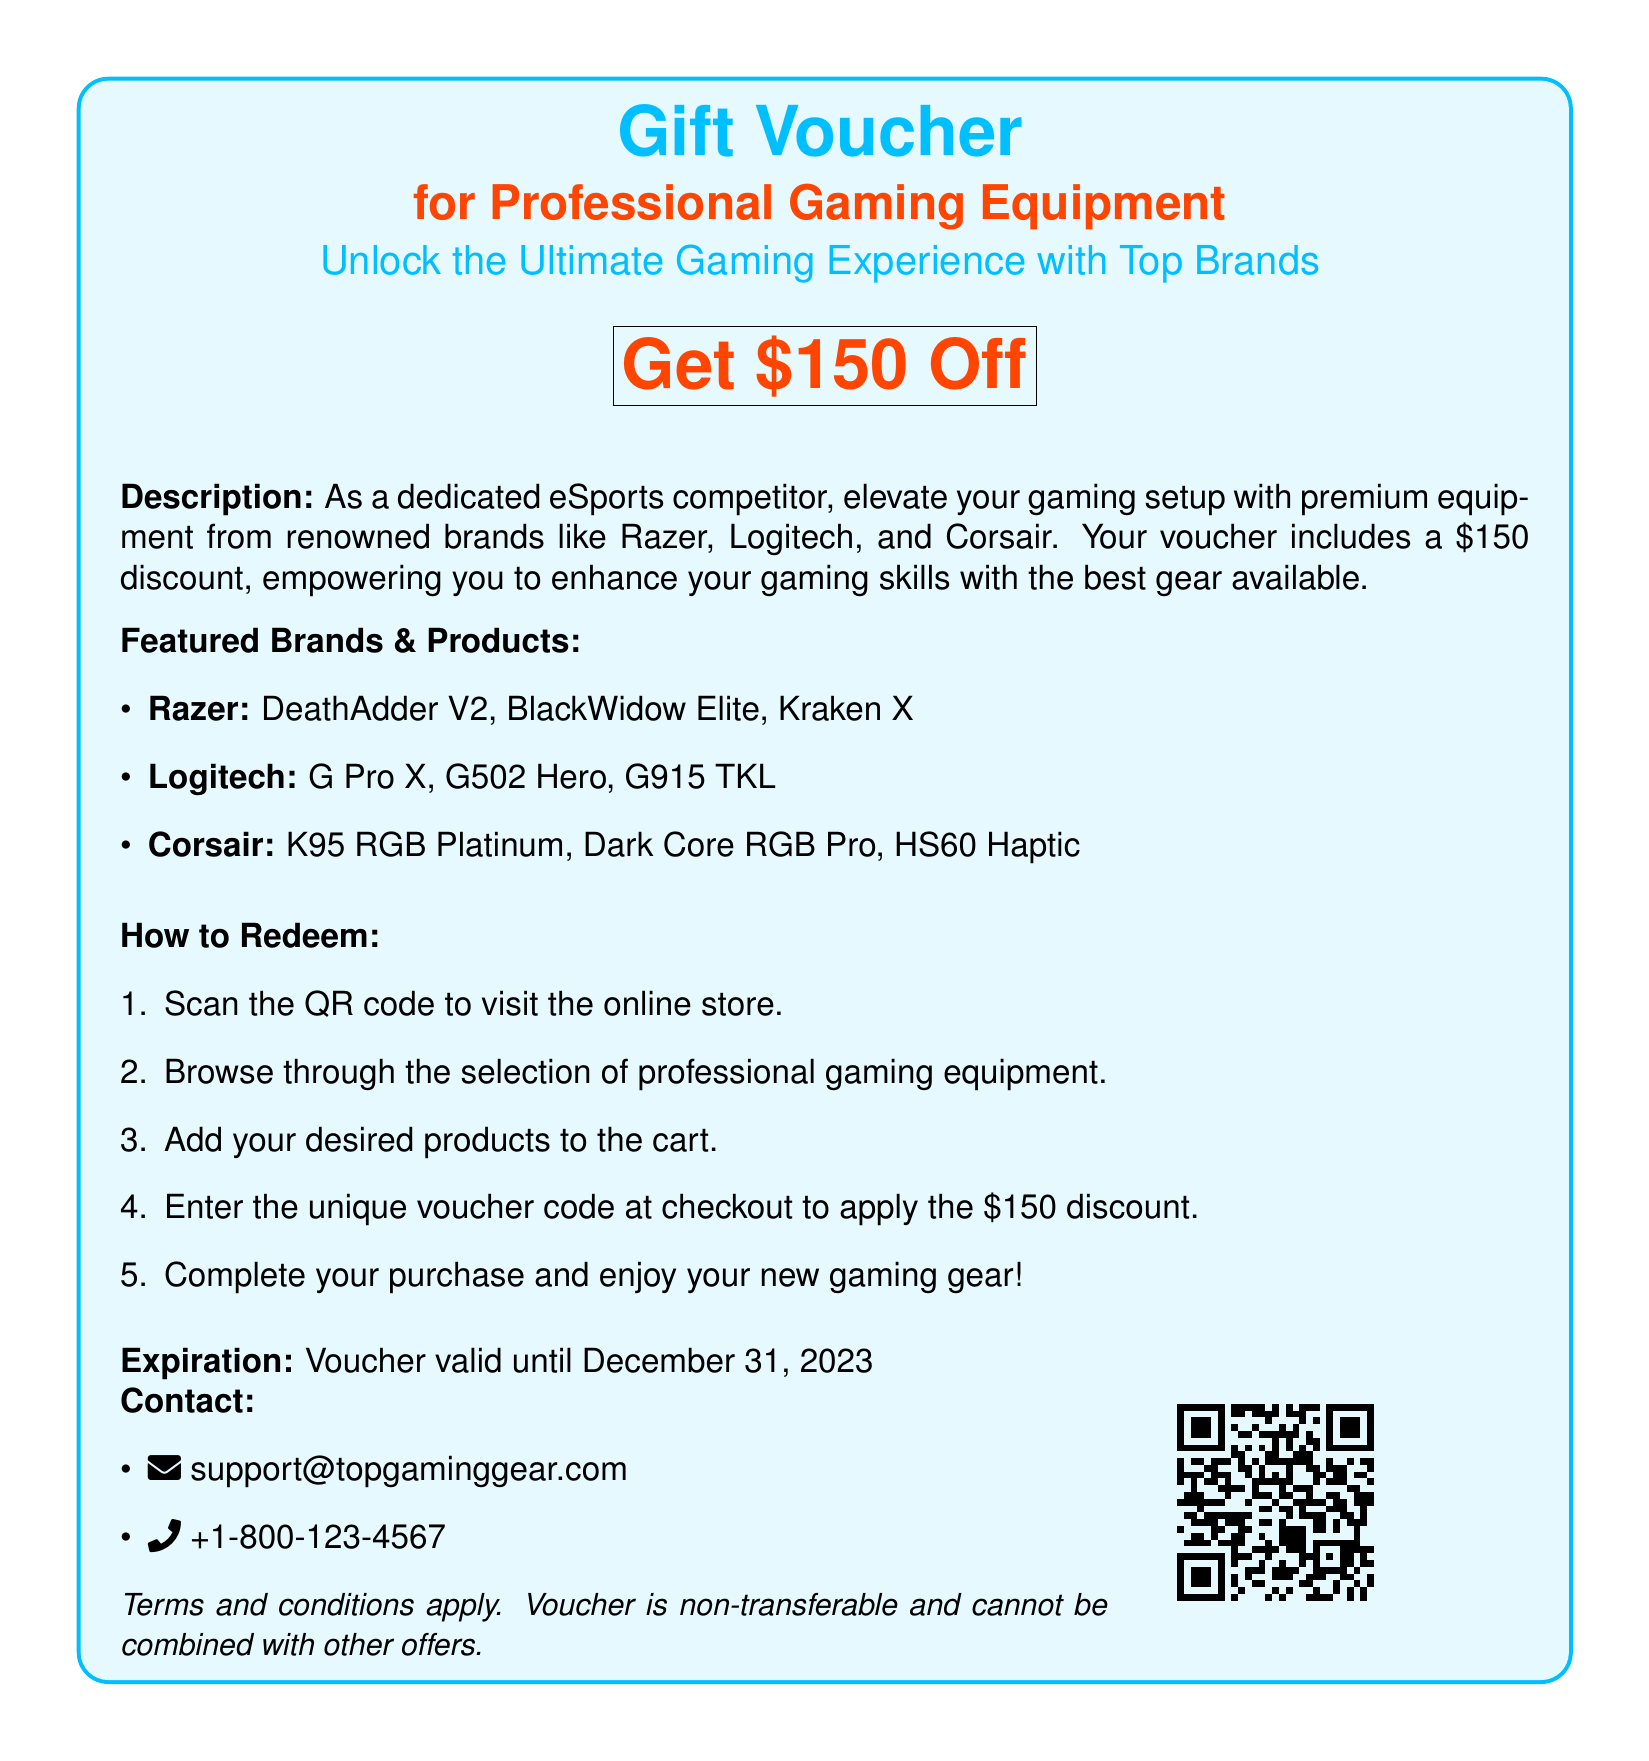What is the discount amount? The document states that the voucher offers a discount of $150.
Answer: $150 Which brands are featured in the voucher? The voucher mentions three brands: Razer, Logitech, and Corsair.
Answer: Razer, Logitech, Corsair What is the expiration date of the voucher? The document indicates that the voucher is valid until December 31, 2023.
Answer: December 31, 2023 How many steps are there to redeem the voucher? The document lists a total of five steps for redeeming the voucher.
Answer: Five What is required to redeem the voucher? The document specifies entering a unique voucher code at checkout to apply the discount.
Answer: Unique voucher code Which product is associated with Razer? The voucher lists several products, one of which is the DeathAdder V2 associated with Razer.
Answer: DeathAdder V2 What should you do first to redeem the voucher? The first step in redeeming the voucher is to scan the QR code.
Answer: Scan the QR code What type of document is this? The document is a gift voucher specifically for professional gaming equipment.
Answer: Gift voucher 